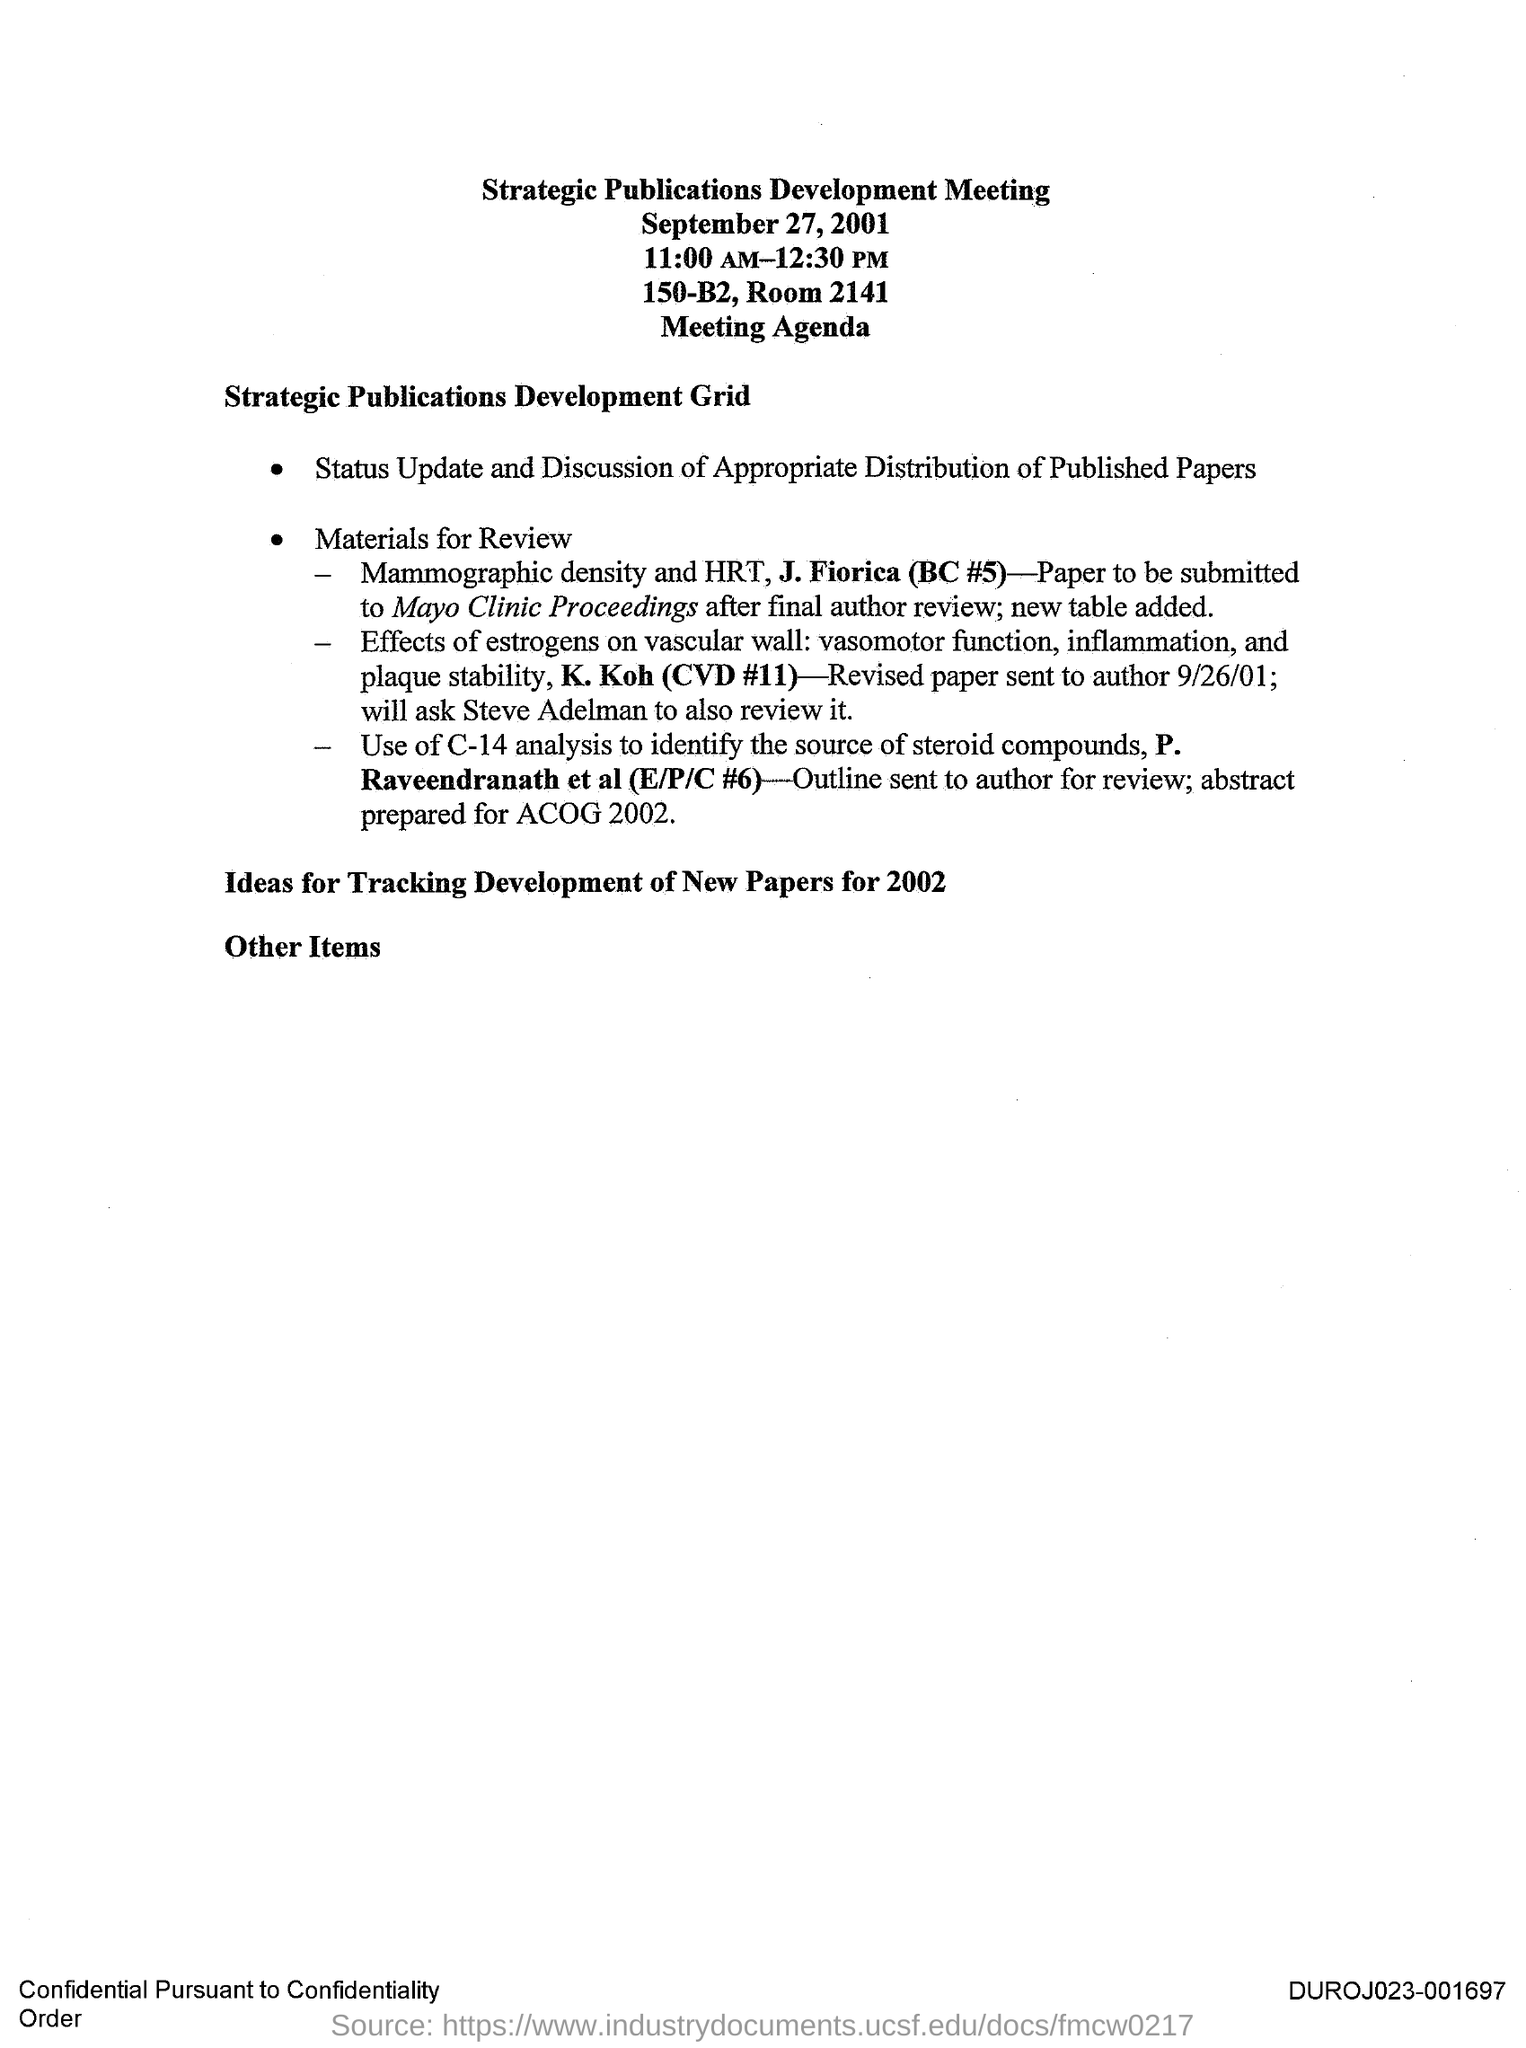Indicate a few pertinent items in this graphic. The Strategic Publications Development Meeting is held at 150-B2. The Strategic Publications Development Meeting was held on September 27, 2001. The revised paper was sent to the author on September 26, 2001. The Strategic Publications Development Meeting is held at 11:00 AM-12:30 PM. 